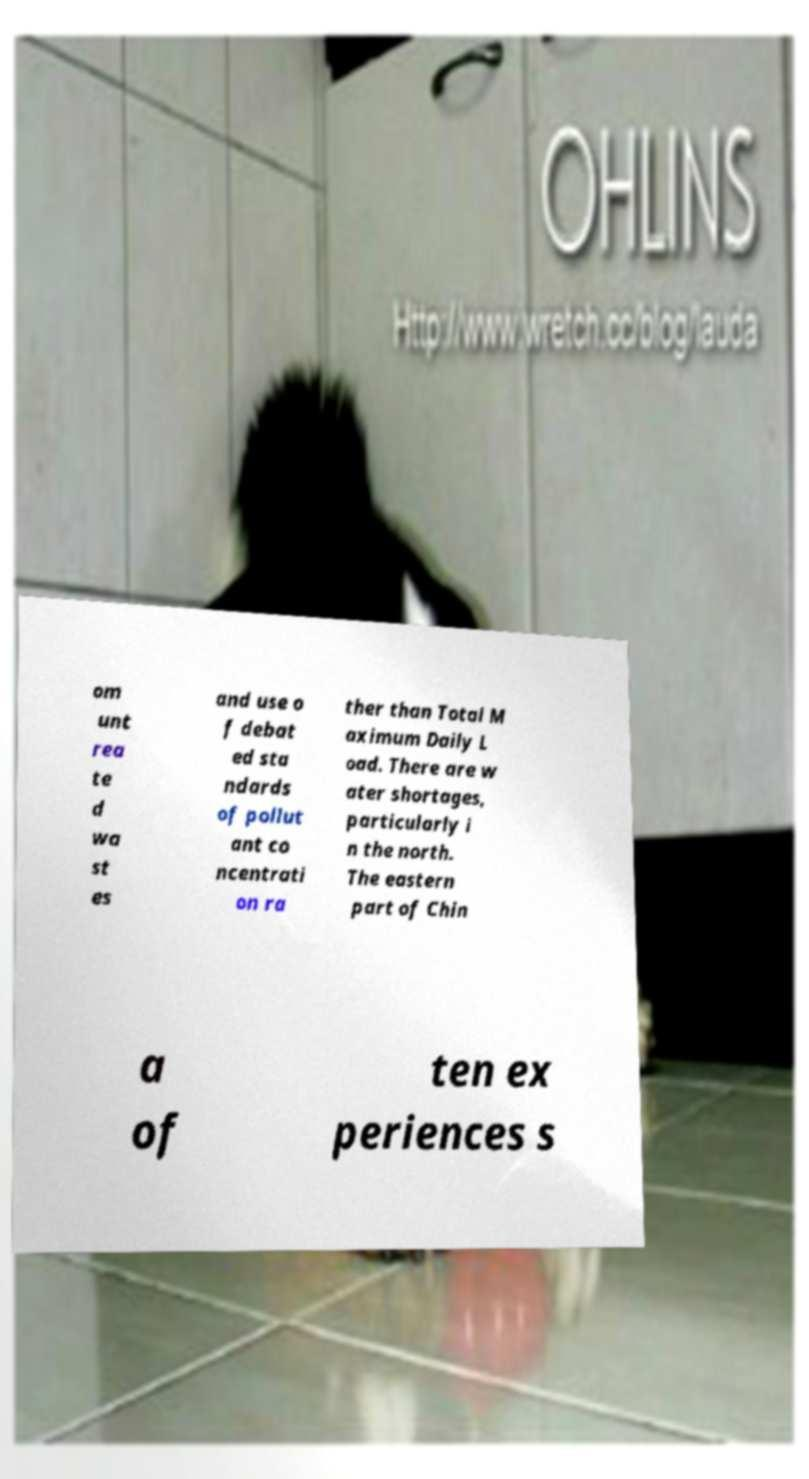Please read and relay the text visible in this image. What does it say? om unt rea te d wa st es and use o f debat ed sta ndards of pollut ant co ncentrati on ra ther than Total M aximum Daily L oad. There are w ater shortages, particularly i n the north. The eastern part of Chin a of ten ex periences s 